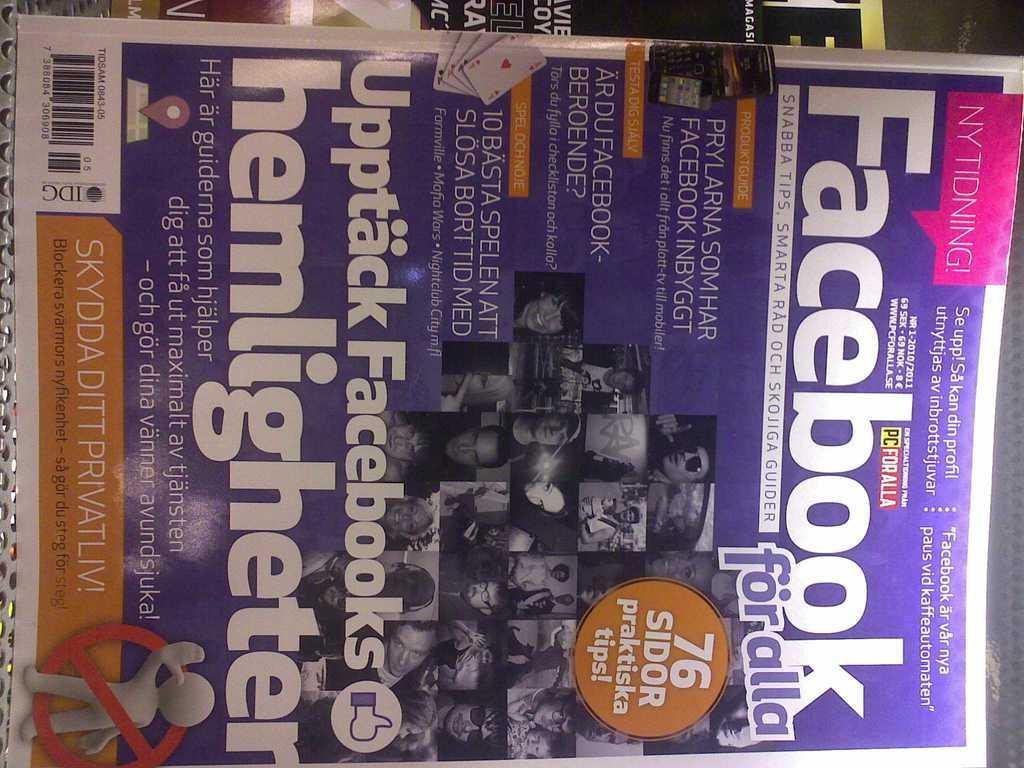<image>
Share a concise interpretation of the image provided. Facebook For alla on the front of a magazine cover. 